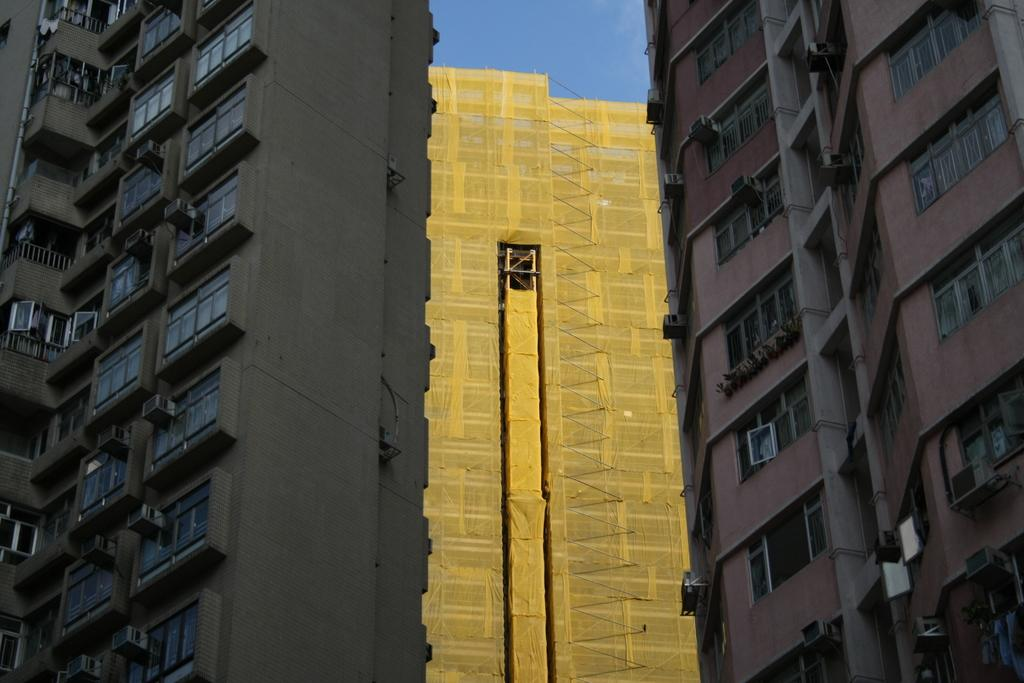What type of structures can be seen in the image? There are buildings in the image. What feature is present on the buildings? There are windows in the image. What part of the natural environment is visible in the image? The sky is visible in the image. How many loaves of bread can be seen on the windowsill in the image? There is no bread present in the image; it features buildings with windows and a visible sky. What type of lizards can be seen climbing on the buildings in the image? There are no lizards present in the image; it only shows buildings with windows and a visible sky. 